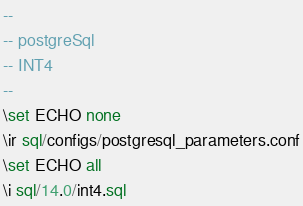<code> <loc_0><loc_0><loc_500><loc_500><_SQL_>--
-- postgreSql
-- INT4
--
\set ECHO none
\ir sql/configs/postgresql_parameters.conf
\set ECHO all
\i sql/14.0/int4.sql
</code> 